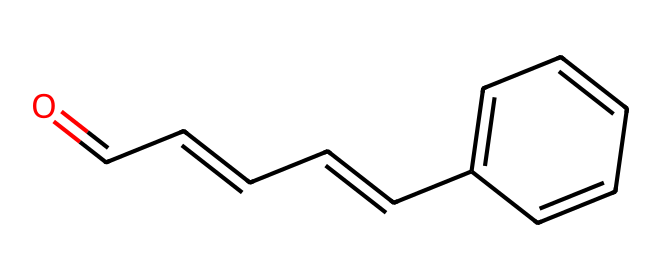What is the functional group present in cinnamaldehyde? The functional group is identified by the presence of the aldehyde carbonyl (C=O) at the end of the molecule, which distinguishes it from other types of compounds.
Answer: aldehyde How many carbon atoms are in the cinnamaldehyde structure? By analyzing the SMILES representation, we can count the number of carbon atoms present. There are 9 carbon atoms in total from the structure represented as O=CC=CC=Cc1ccccc1.
Answer: 9 What type of chemical bond is present between the carbon atoms in the double bonds? The structure displays double bonds between certain carbon atoms, which are indicated by the '=' symbols in the SMILES representation, making them alkenes.
Answer: double bond What is the molecular formula of cinnamaldehyde? To determine the molecular formula, we count the individual types of atoms present in the SMILES: C9H8O. Combine these counts to create the formula.
Answer: C9H8O How many double bonds are in the structure of cinnamaldehyde? By examining the structure, we see that there are three double bonds formed between carbon atoms and one carbonyl double bond, totaling four.
Answer: 4 Which part of the structure contributes to the flavor of the chemical? The carbonyl group (C=O) in the aldehyde functional group significantly contributes to the flavor characteristics of the compound.
Answer: carbonyl group Is cinnamaldehyde a natural or synthetic compound? Cinnamaldehyde is primarily derived from natural sources, particularly cinnamon oil, making it a naturally occurring compound.
Answer: natural 